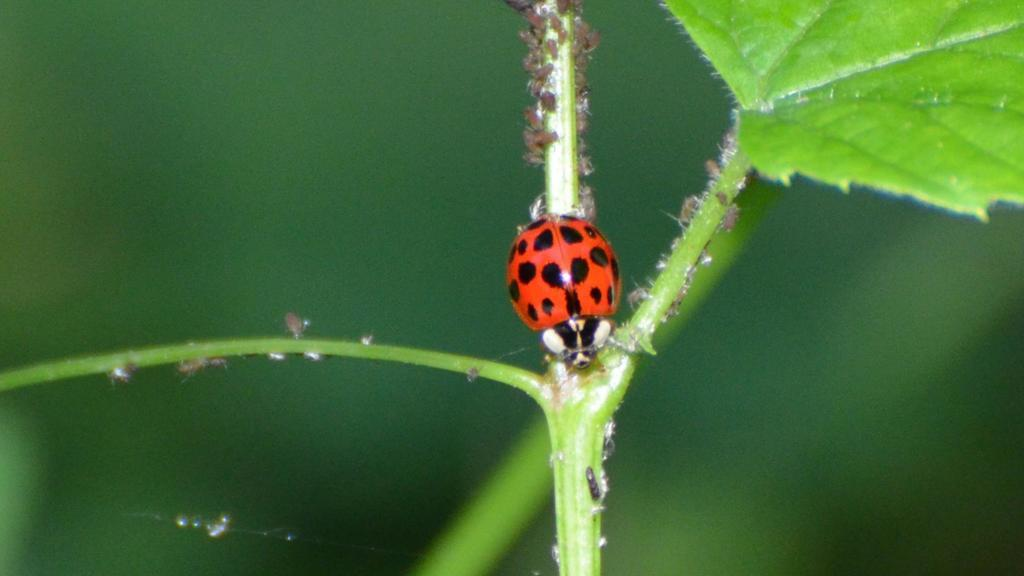What insect is present in the image? There is a ladybird beetle in the image. Where is the ladybird beetle located? The ladybird beetle is on a stem in the image. What type of plant part is visible in the image? There is a leaf in the image. What is the color of the leaf? The leaf is green in color. How would you describe the background of the image? The background of the image appears blurry. What channel is the ladybird beetle watching on the stem? There is no television or channel present in the image; it features a ladybird beetle on a stem. What type of arithmetic problem can be solved using the leaf in the image? There is no arithmetic problem or reference to math in the image; it features a ladybird beetle on a stem and a green leaf. 